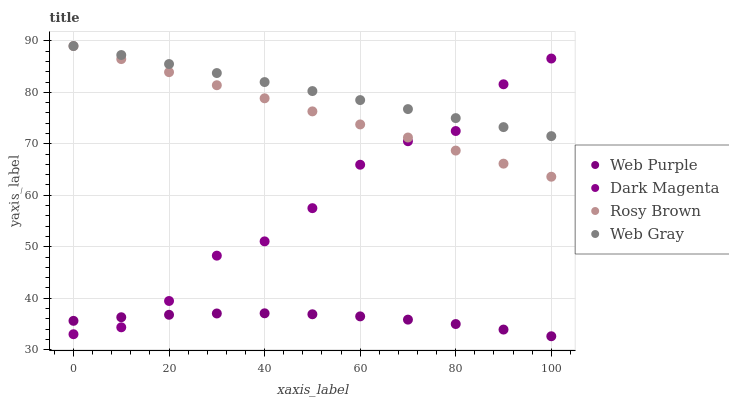Does Web Purple have the minimum area under the curve?
Answer yes or no. Yes. Does Web Gray have the maximum area under the curve?
Answer yes or no. Yes. Does Rosy Brown have the minimum area under the curve?
Answer yes or no. No. Does Rosy Brown have the maximum area under the curve?
Answer yes or no. No. Is Web Gray the smoothest?
Answer yes or no. Yes. Is Dark Magenta the roughest?
Answer yes or no. Yes. Is Rosy Brown the smoothest?
Answer yes or no. No. Is Rosy Brown the roughest?
Answer yes or no. No. Does Web Purple have the lowest value?
Answer yes or no. Yes. Does Rosy Brown have the lowest value?
Answer yes or no. No. Does Web Gray have the highest value?
Answer yes or no. Yes. Does Dark Magenta have the highest value?
Answer yes or no. No. Is Web Purple less than Web Gray?
Answer yes or no. Yes. Is Web Gray greater than Web Purple?
Answer yes or no. Yes. Does Rosy Brown intersect Web Gray?
Answer yes or no. Yes. Is Rosy Brown less than Web Gray?
Answer yes or no. No. Is Rosy Brown greater than Web Gray?
Answer yes or no. No. Does Web Purple intersect Web Gray?
Answer yes or no. No. 